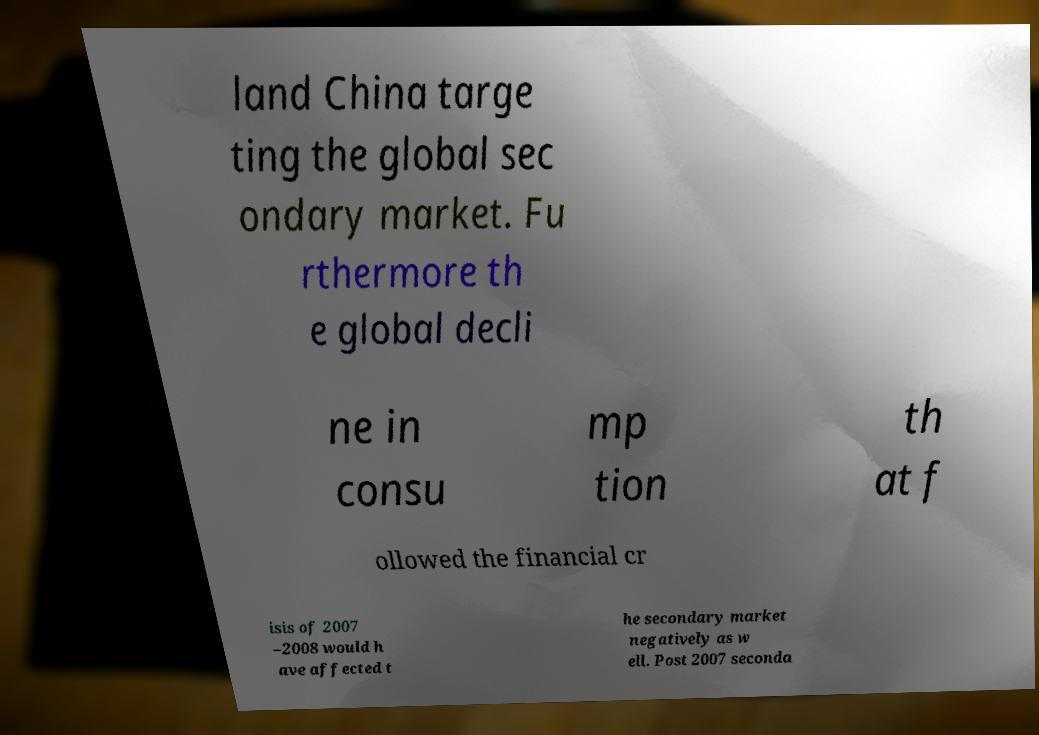Could you assist in decoding the text presented in this image and type it out clearly? land China targe ting the global sec ondary market. Fu rthermore th e global decli ne in consu mp tion th at f ollowed the financial cr isis of 2007 –2008 would h ave affected t he secondary market negatively as w ell. Post 2007 seconda 